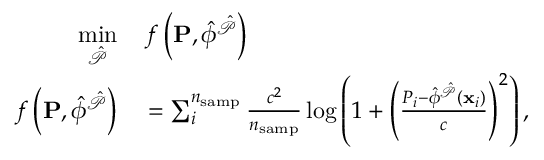<formula> <loc_0><loc_0><loc_500><loc_500>\begin{array} { r l } { \underset { \hat { \mathcal { P } } } { \min } } & \, f \left ( P , \hat { \phi } ^ { \hat { \mathcal { P } } } \right ) } \\ { f \left ( P , \hat { \phi } ^ { \hat { \mathcal { P } } } \right ) } & = \sum _ { i } ^ { n _ { s a m p } } \frac { c ^ { 2 } } { n _ { s a m p } } \log \left ( 1 + \left ( \frac { P _ { i } - \hat { \phi } ^ { \hat { \mathcal { P } } } \left ( x _ { i } \right ) } { c } \right ) ^ { 2 } \right ) , } \end{array}</formula> 